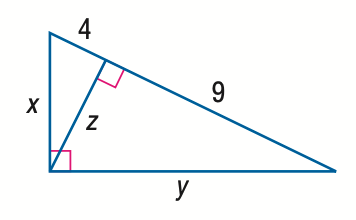What can you tell me about the history of the Pythagorean theorem? The Pythagorean theorem is named after the ancient Greek mathematician Pythagoras, who is credited with its discovery, although evidence suggests that the theorem was known and used by Babylonian and Indian mathematicians before him. The theorem establishes a fundamental relationship in Euclidean geometry among the three sides of a right triangle. It has been proved in numerous ways over the centuries and remains one of the most important theorems in mathematics because of its wide-ranging implications and applications. 